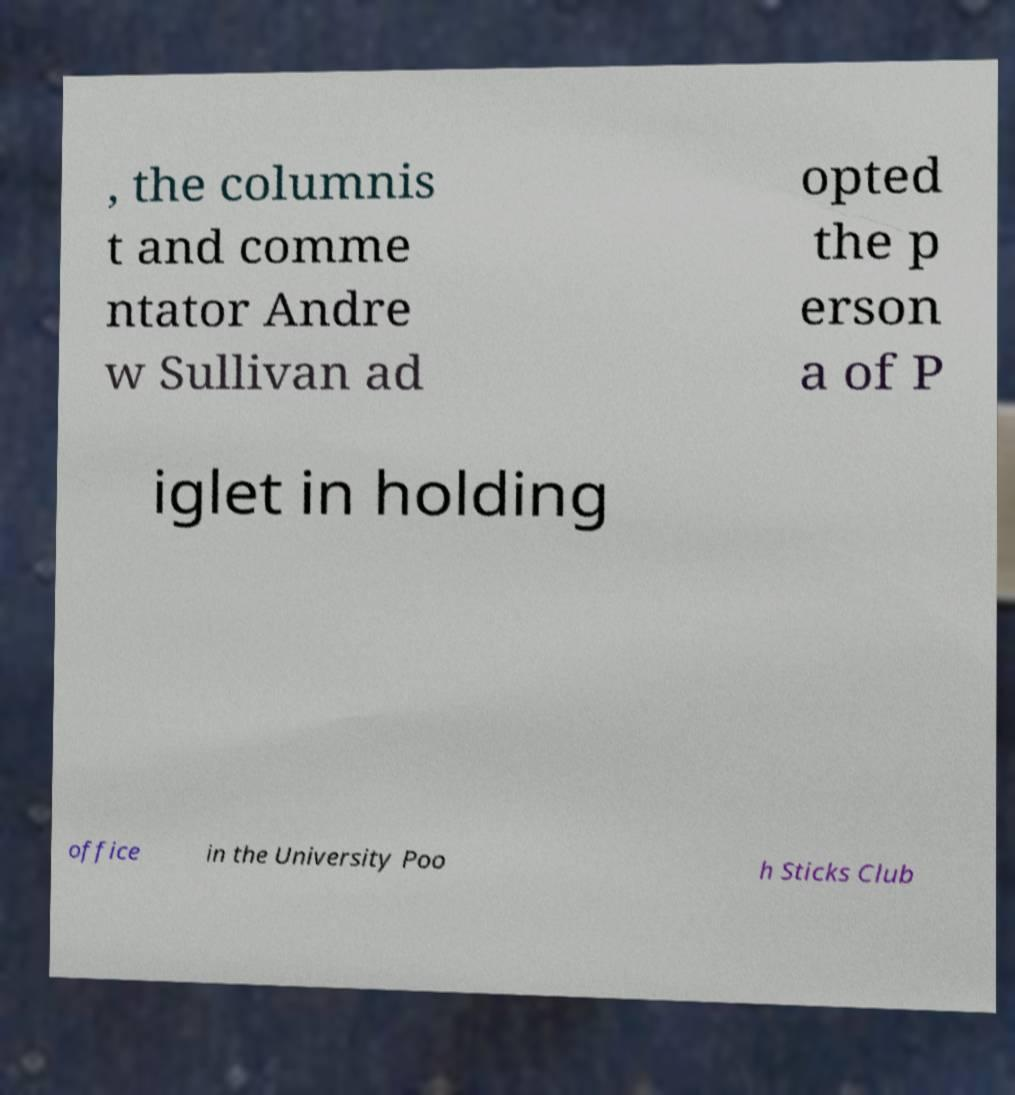What messages or text are displayed in this image? I need them in a readable, typed format. , the columnis t and comme ntator Andre w Sullivan ad opted the p erson a of P iglet in holding office in the University Poo h Sticks Club 